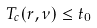<formula> <loc_0><loc_0><loc_500><loc_500>T _ { c } ( r , \nu ) \leq t _ { 0 }</formula> 